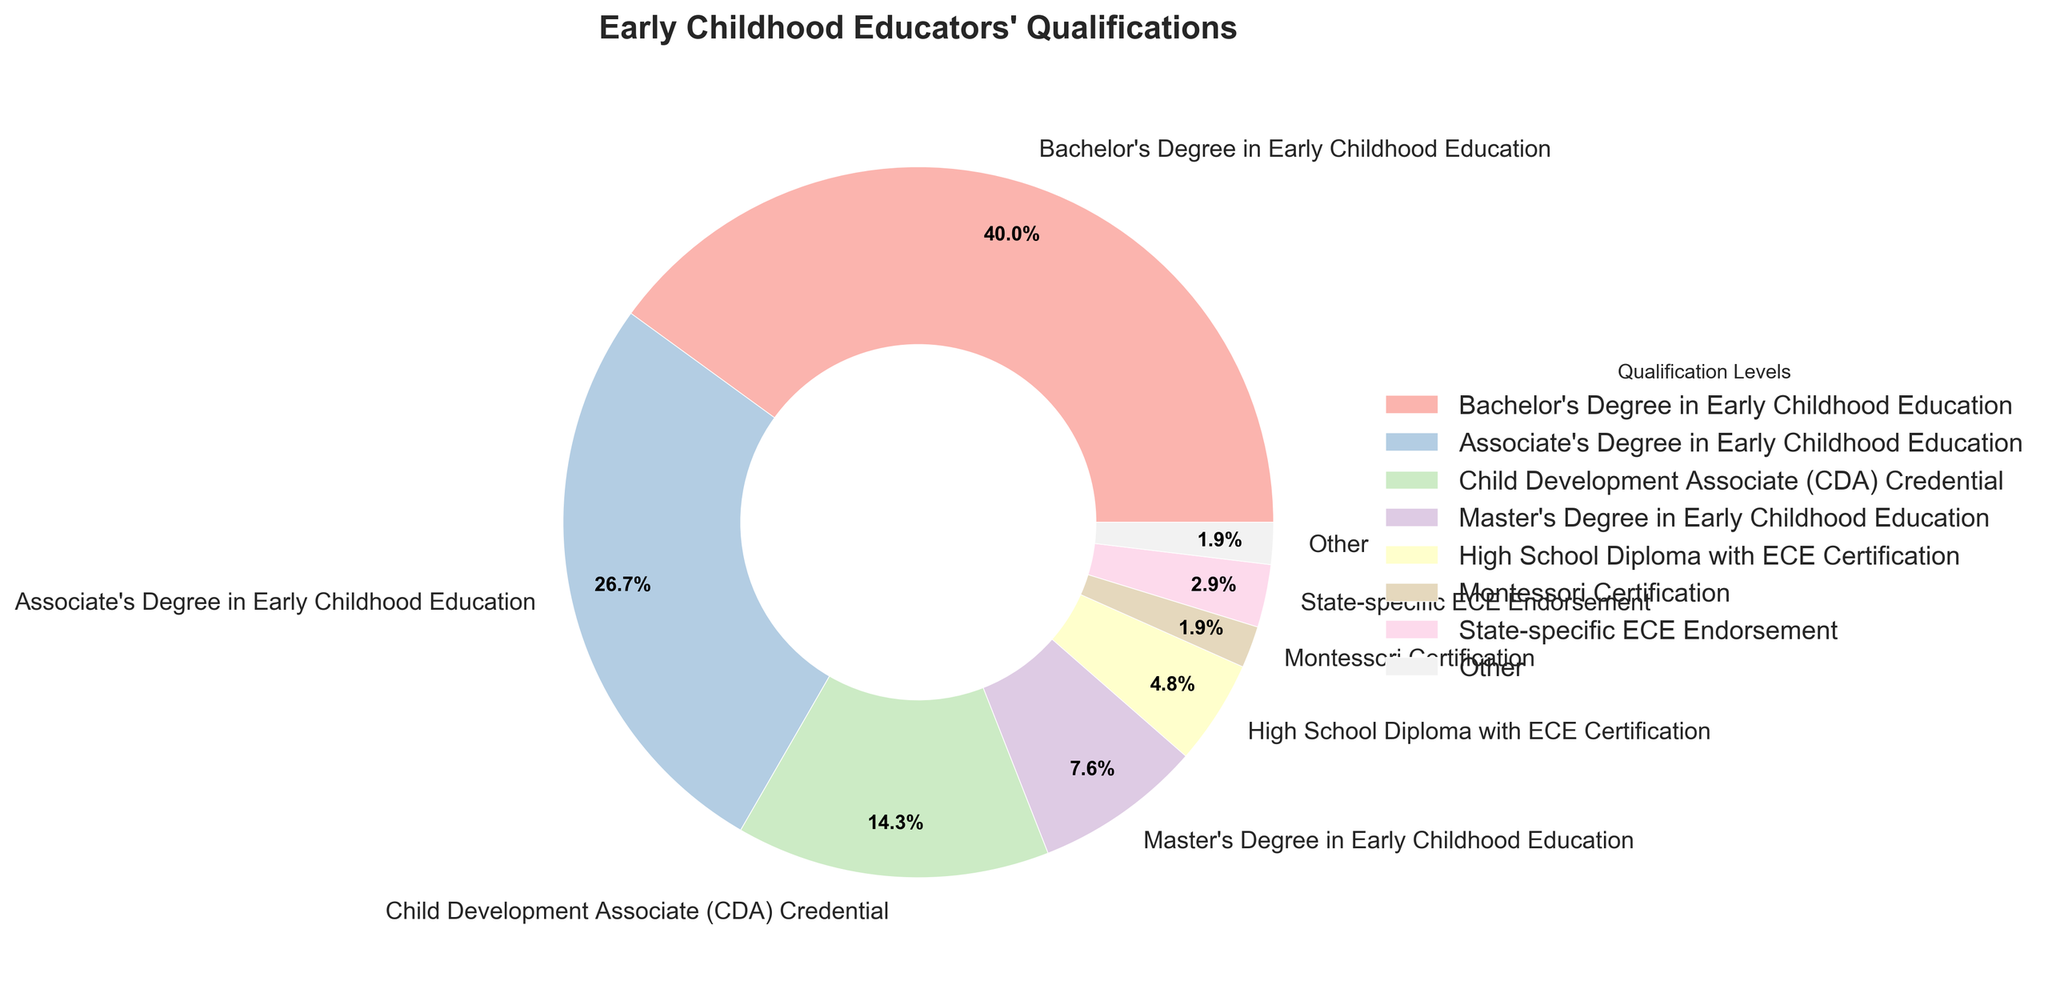what is the most common qualification among early childhood educators? The pie chart shows the percentage distribution of early childhood educators' qualifications. The largest slice corresponds to "Bachelor's Degree in Early Childhood Education," which has the highest percentage.
Answer: Bachelor's Degree in Early Childhood Education What percentage of early childhood educators have either a Bachelor's or an Associate's degree in Early Childhood Education? Add the percentages for educators with a Bachelor's Degree (42%) and those with an Associate's Degree (28%). 42% + 28% = 70%
Answer: 70% Which has a higher percentage, educators with a Master's Degree or those with a Child Development Associate (CDA) Credential? Compare the percentages for Master's Degree holders (8%) and CDA Credential holders (15%). 15% is greater than 8%.
Answer: CDA Credential What is the combined percentage of all qualifications labeled as "Other"? From the figure, the "Other" category includes all qualifications below the threshold of 2%. By summing the "Doctoral Degree," "Waldorf Teacher Certification," and "No formal ECE qualification" percentages (0.5% + 1% + 0.5%), we see that it sums up to 2%.
Answer: 2% Which qualification category is represented by the smallest slice? The smallest slice in the pie chart corresponds to "No formal ECE qualification" and "Doctoral Degree," both at 0.5%.
Answer: No formal ECE qualification and Doctoral Degree How does the percentage of educators with state-specific ECE Endorsement compare to those without any formal ECE qualification? Compare the two percentages: educators with state-specific ECE Endorsement have 3%, while those without any formal ECE qualification have 0.5%. 3% is greater than 0.5%.
Answer: State-specific ECE Endorsement Given the data, what is the average percentage for all qualification levels included in the "Other" category? First, sum the percentages of the qualifications in the "Other" category: 0.5% (Doctoral Degree) + 1% (Waldorf Teacher Certification) + 0.5% (No formal ECE qualification) = 2%. Since there are three categories, the average is 2% / 3 = 0.67%.
Answer: 0.67% Which qualifications together make up over 80% of the educators? Add the percentages for the largest slices until the sum exceeds 80%. Bachelor's Degree (42%) + Associate's Degree (28%) + CDA Credential (15%): 42% + 28% + 15% = 85%.
Answer: Bachelor's Degree, Associate's Degree, and CDA Credential What is the difference in percentage between educators with an Associate's Degree and those with a Master's Degree in Early Childhood Education? Subtract the percentage of educators with a Master's Degree (8%) from those with an Associate's Degree (28%): 28% - 8% = 20%.
Answer: 20% 